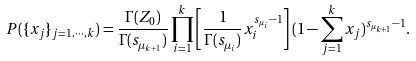Convert formula to latex. <formula><loc_0><loc_0><loc_500><loc_500>P ( \{ x _ { j } \} _ { j = 1 , \cdots , k } ) = \frac { \Gamma ( Z _ { 0 } ) } { \Gamma ( s _ { \mu _ { k + 1 } } ) } \prod _ { i = 1 } ^ { k } \left [ \frac { 1 } { \Gamma ( s _ { \mu _ { i } } ) } x _ { i } ^ { s _ { \mu _ { i } } - 1 } \right ] ( 1 - \sum _ { j = 1 } ^ { k } x _ { j } ) ^ { s _ { \mu _ { k + 1 } } - 1 } .</formula> 